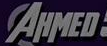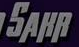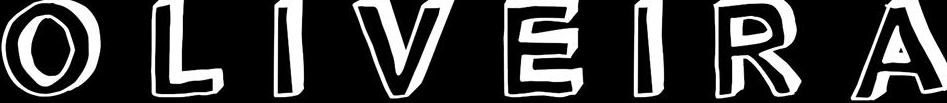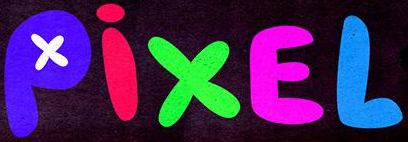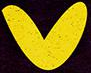What words are shown in these images in order, separated by a semicolon? AHMED; SAHR; OLIVEIRA; PixEL; v 